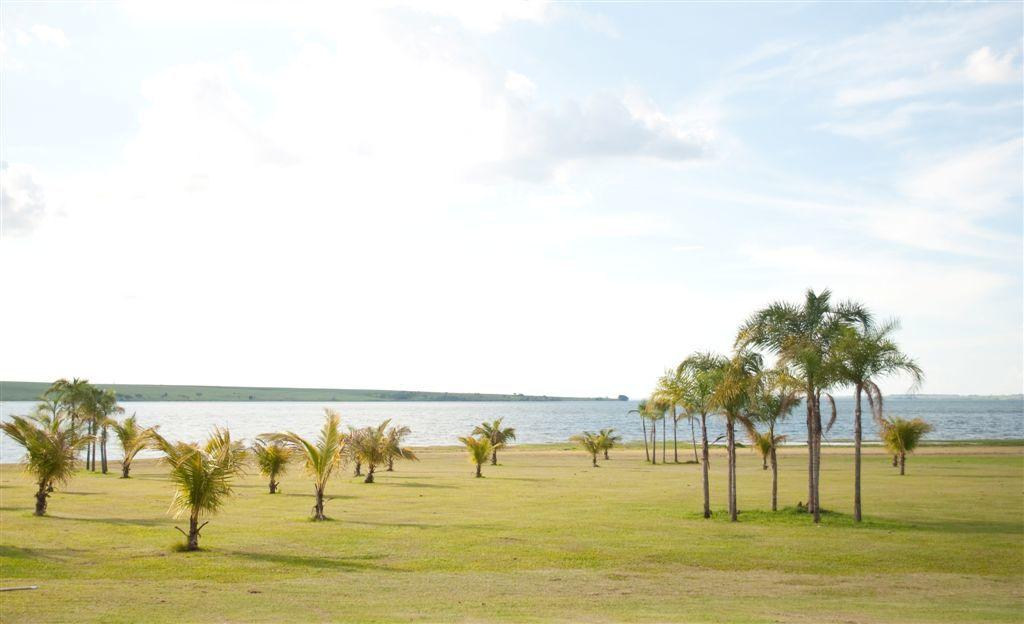What type of vegetation can be seen in the image? There are trees in the image. What can be seen in the background of the image? There is water and clouds visible in the background of the image. What type of meat is being grilled in the image? There is no meat or grilling activity present in the image. 